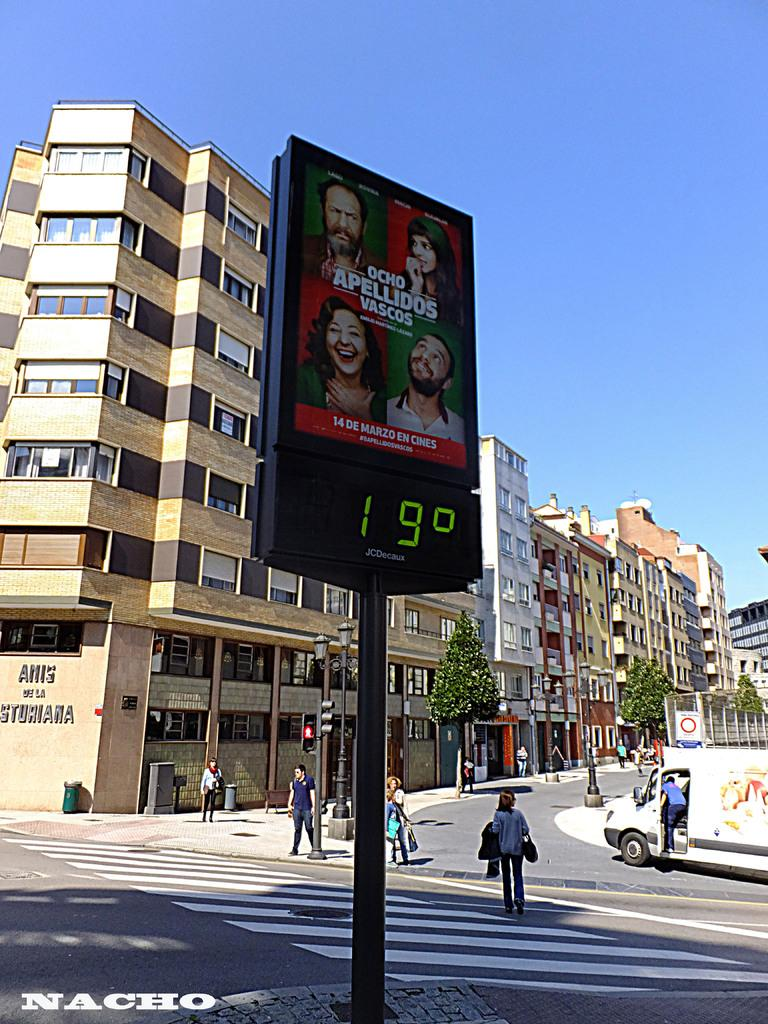Provide a one-sentence caption for the provided image. A warm cloudless day outside, with a temperature of 19c. 